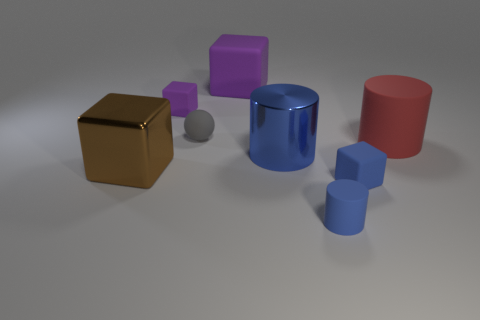Subtract all rubber cylinders. How many cylinders are left? 1 Add 1 large gray shiny balls. How many objects exist? 9 Subtract all blue cylinders. How many cylinders are left? 1 Subtract 2 blocks. How many blocks are left? 2 Subtract 1 brown cubes. How many objects are left? 7 Subtract all spheres. How many objects are left? 7 Subtract all brown blocks. Subtract all red balls. How many blocks are left? 3 Subtract all gray balls. How many gray cylinders are left? 0 Subtract all purple things. Subtract all purple things. How many objects are left? 4 Add 8 rubber balls. How many rubber balls are left? 9 